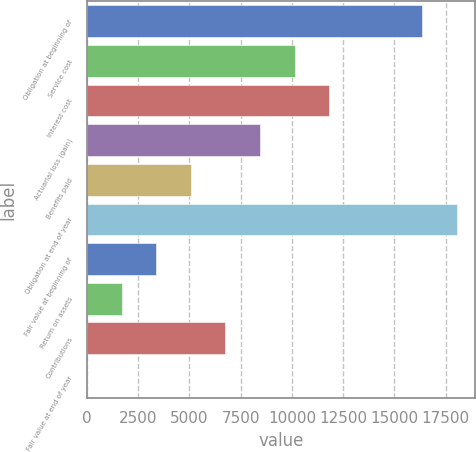Convert chart to OTSL. <chart><loc_0><loc_0><loc_500><loc_500><bar_chart><fcel>Obligation at beginning of<fcel>Service cost<fcel>Interest cost<fcel>Actuarial loss (gain)<fcel>Benefits paid<fcel>Obligation at end of year<fcel>Fair value at beginning of<fcel>Return on assets<fcel>Contributions<fcel>Fair value at end of year<nl><fcel>16340<fcel>10133.6<fcel>11822.5<fcel>8444.79<fcel>5067.11<fcel>18028.8<fcel>3378.27<fcel>1689.43<fcel>6755.95<fcel>0.59<nl></chart> 